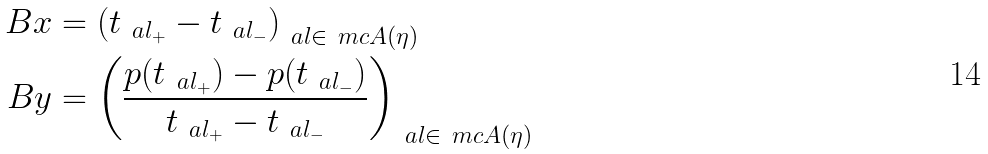Convert formula to latex. <formula><loc_0><loc_0><loc_500><loc_500>\ B x & = \left ( t _ { \ a l _ { + } } - t _ { \ a l _ { - } } \right ) _ { \ a l \in \ m c A ( \eta ) } \\ \ B y & = \left ( \frac { p ( t _ { \ a l _ { + } } ) - p ( t _ { \ a l _ { - } } ) } { t _ { \ a l _ { + } } - t _ { \ a l _ { - } } } \right ) _ { \ a l \in \ m c A ( \eta ) }</formula> 